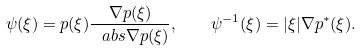Convert formula to latex. <formula><loc_0><loc_0><loc_500><loc_500>\psi ( \xi ) = p ( \xi ) \frac { \nabla p ( \xi ) } { \ a b s { \nabla p ( \xi ) } } , \quad \psi ^ { - 1 } ( \xi ) = | \xi | \nabla p ^ { * } ( \xi ) .</formula> 